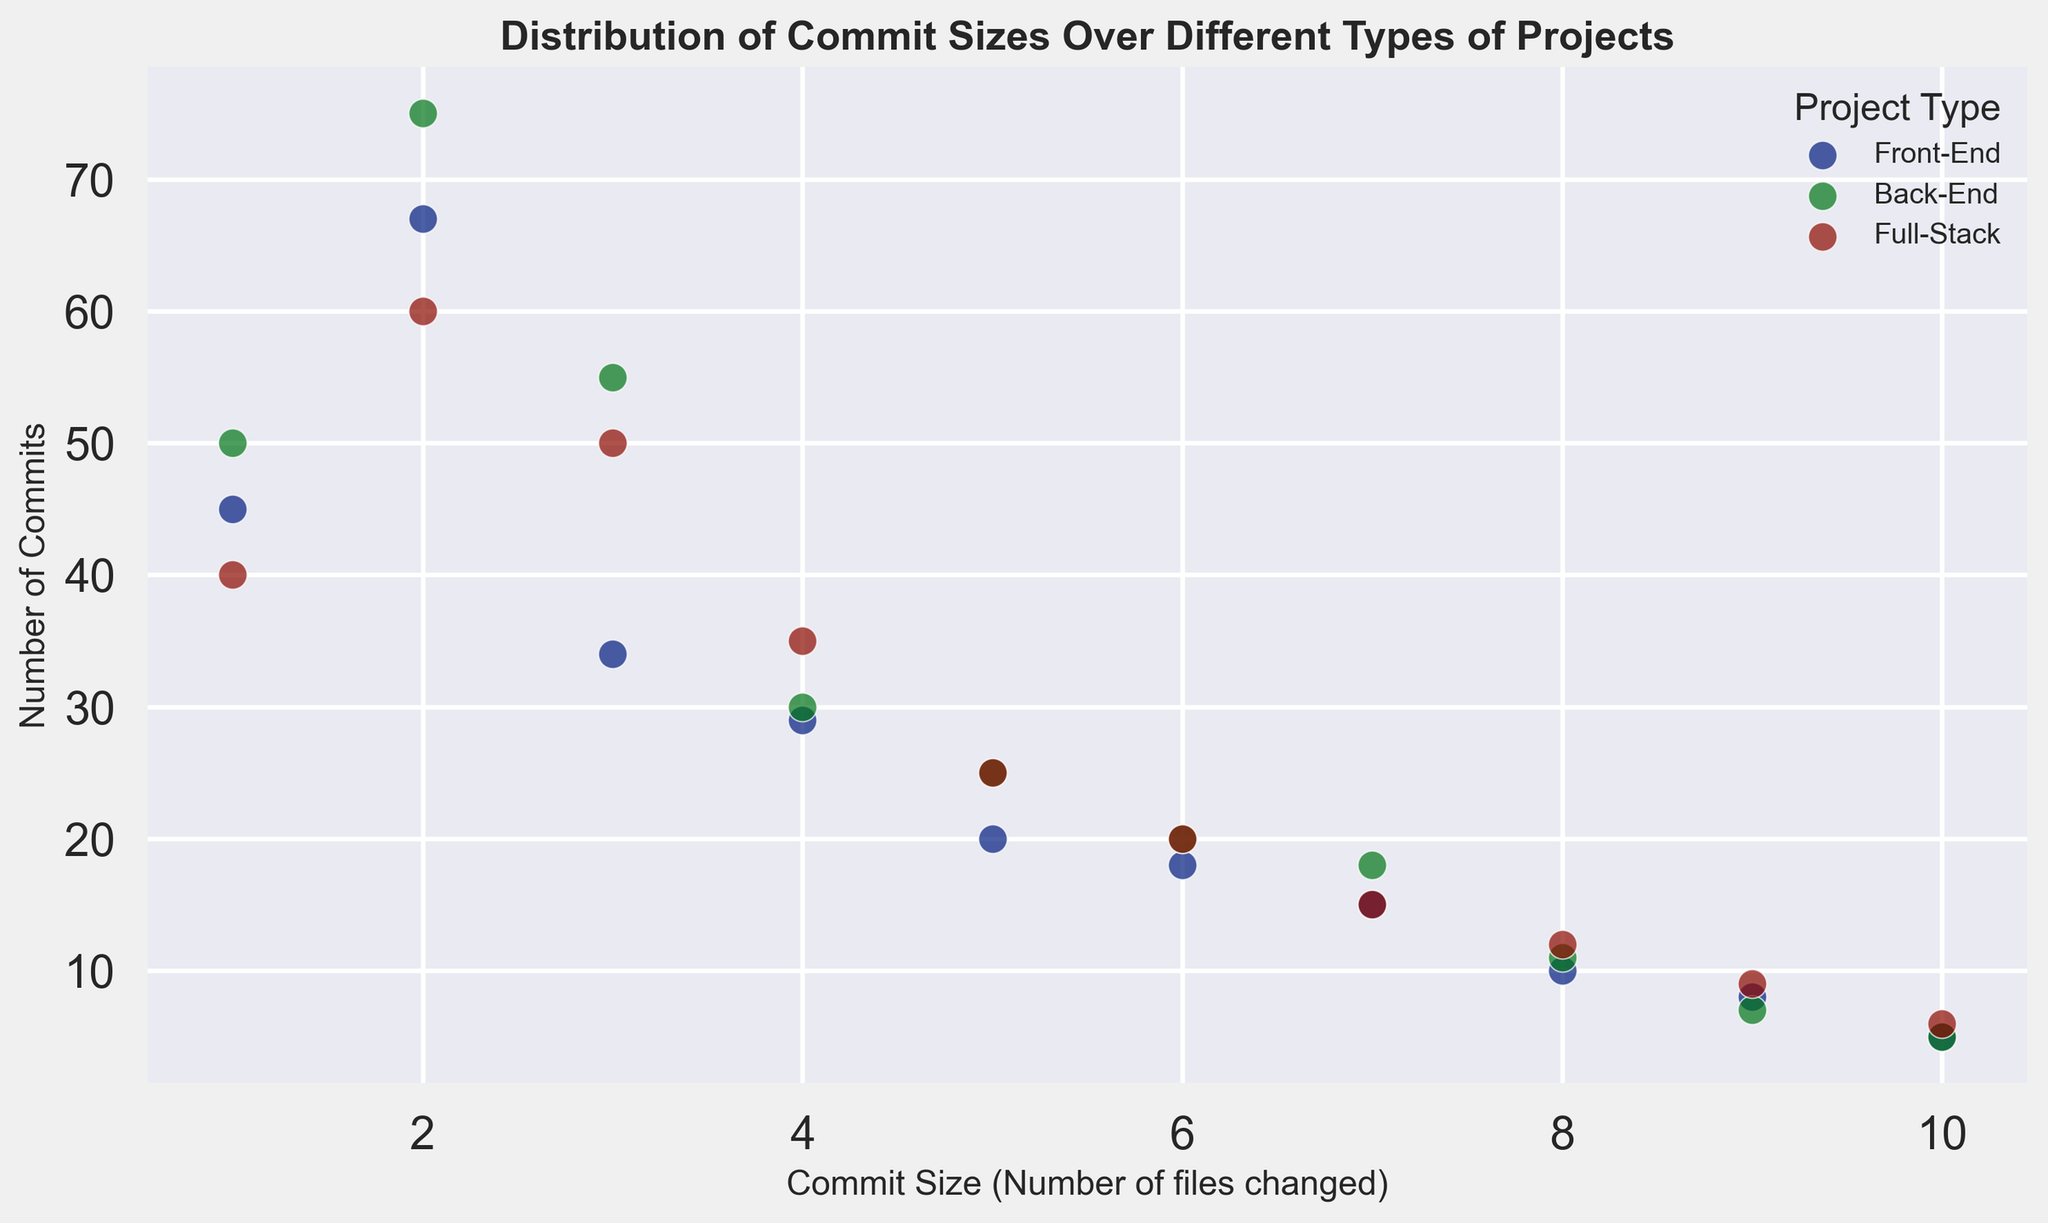Which project type has the highest number of commits for a commit size of 3? By looking at the points along the commit size of 3 on the x-axis, we see Front-End: 34, Back-End: 55, Full-Stack: 50. Among these, the Back-End has the highest value.
Answer: Back-End In which project type is the trend of decreasing number of commits with increased commit size less steep (most gradual decrease)? Observing the slopes of the data points, the Full-Stack project type shows fewer drastic drops, showing a more gradual decrease compared to Front-End and Back-End.
Answer: Full-Stack What is the difference in the number of commits between the Front-End and Back-End projects for a commit size of 10? At commit size 10, the number of commits for Front-End is 5, and for Back-End is also 5. So the difference is 5 - 5 = 0.
Answer: 0 Which project type has the most number of commits for a commit size of 1? By looking at the points along the commit size of 1 on the x-axis, we see Front-End: 45, Back-End: 50, Full-Stack: 40. Among these, the Back-End has the highest value.
Answer: Back-End Between commit sizes of 8 and 10, which project type shows the smallest decrease in the number of commits? For Front-End: 10 to 5 (decrease of 5), Back-End: 11 to 5 (decrease of 6), Full-Stack: 12 to 6 (decrease of 6). Front-End shows a decrease of 5 which is the smallest.
Answer: Front-End What is the average number of commits for a commit size of 5 across all project types? Adding the number of commits for commit size 5 across Front-End (20), Back-End (25), and Full-Stack (25) and then taking the average: (20 + 25 + 25)/3 = 24.67.
Answer: 24.67 Which project type has an overall higher number of commits, considering all commit sizes together, Front-End or Full-Stack? Summing up number of commits for all commit sizes: Front-End: (45 + 67 + 34 + 29 + 20 + 18 + 15 + 10 + 8 + 5) = 251, Full-Stack: (40 + 60 + 50 + 35 + 25 + 20 + 15 + 12 + 9 + 6) = 272. Full-Stack has a higher overall number of commits.
Answer: Full-Stack What is the highest number of commits observed across all project types and commit sizes? Looking at the scatter plot, the highest point belongs to commit size 2 for Front-End projects with a value of 67.
Answer: 67 For which commit size do all project types have the exact same number of commits? By observing the plot, at commit size 10, all project types (Front-End, Back-End, and Full-Stack) have 5, 5, and 6 respectively, which are not the same. There is no commit size where all have the exact same commits.
Answer: None For commit size of 6, which project type has the lowest number of commits and what is the value? At commit size 6: Front-End: 18, Back-End: 20, Full-Stack: 20. Among these, the Front-End has the lowest value of 18.
Answer: Front-End, 18 